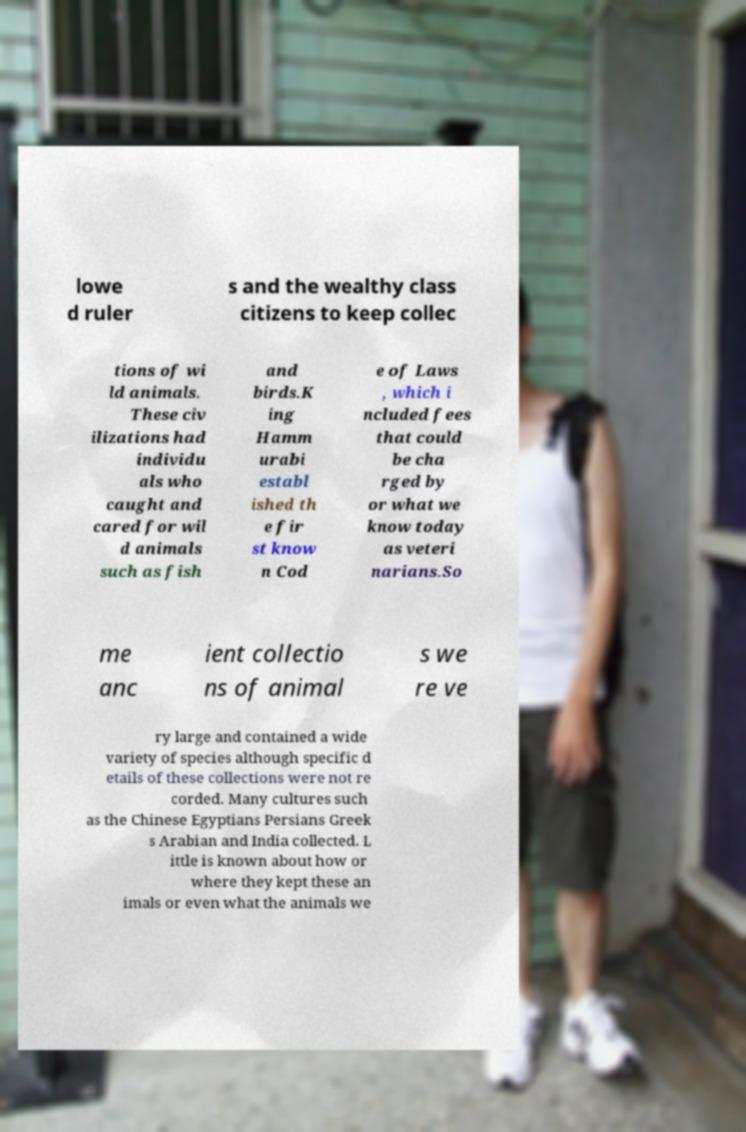Please read and relay the text visible in this image. What does it say? lowe d ruler s and the wealthy class citizens to keep collec tions of wi ld animals. These civ ilizations had individu als who caught and cared for wil d animals such as fish and birds.K ing Hamm urabi establ ished th e fir st know n Cod e of Laws , which i ncluded fees that could be cha rged by or what we know today as veteri narians.So me anc ient collectio ns of animal s we re ve ry large and contained a wide variety of species although specific d etails of these collections were not re corded. Many cultures such as the Chinese Egyptians Persians Greek s Arabian and India collected. L ittle is known about how or where they kept these an imals or even what the animals we 